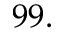<formula> <loc_0><loc_0><loc_500><loc_500>9 9 .</formula> 